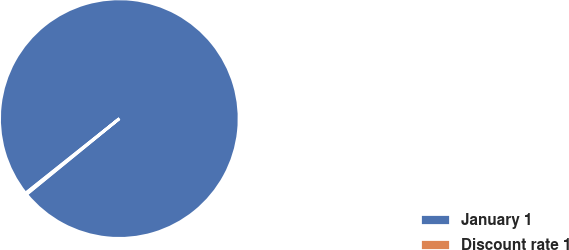<chart> <loc_0><loc_0><loc_500><loc_500><pie_chart><fcel>January 1<fcel>Discount rate 1<nl><fcel>99.79%<fcel>0.21%<nl></chart> 